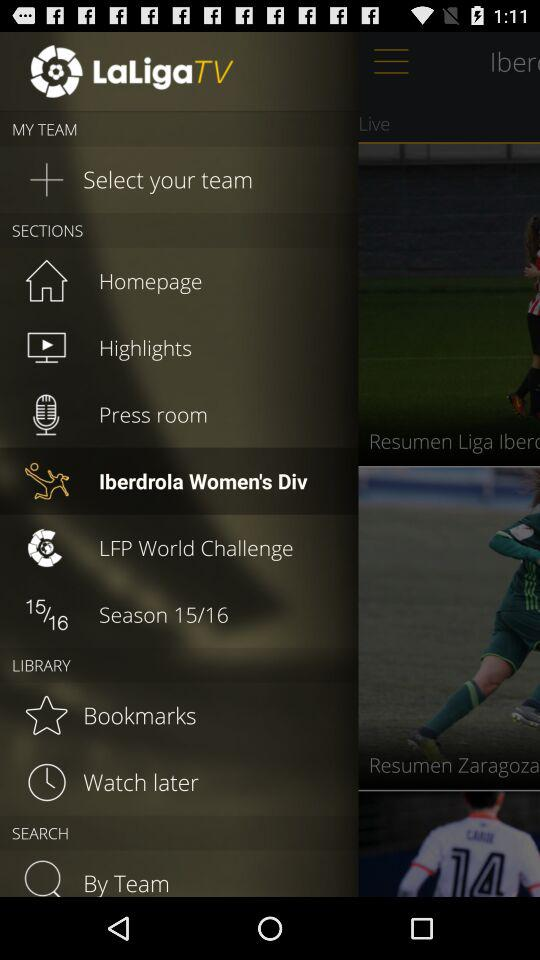Which teams are added?
When the provided information is insufficient, respond with <no answer>. <no answer> 